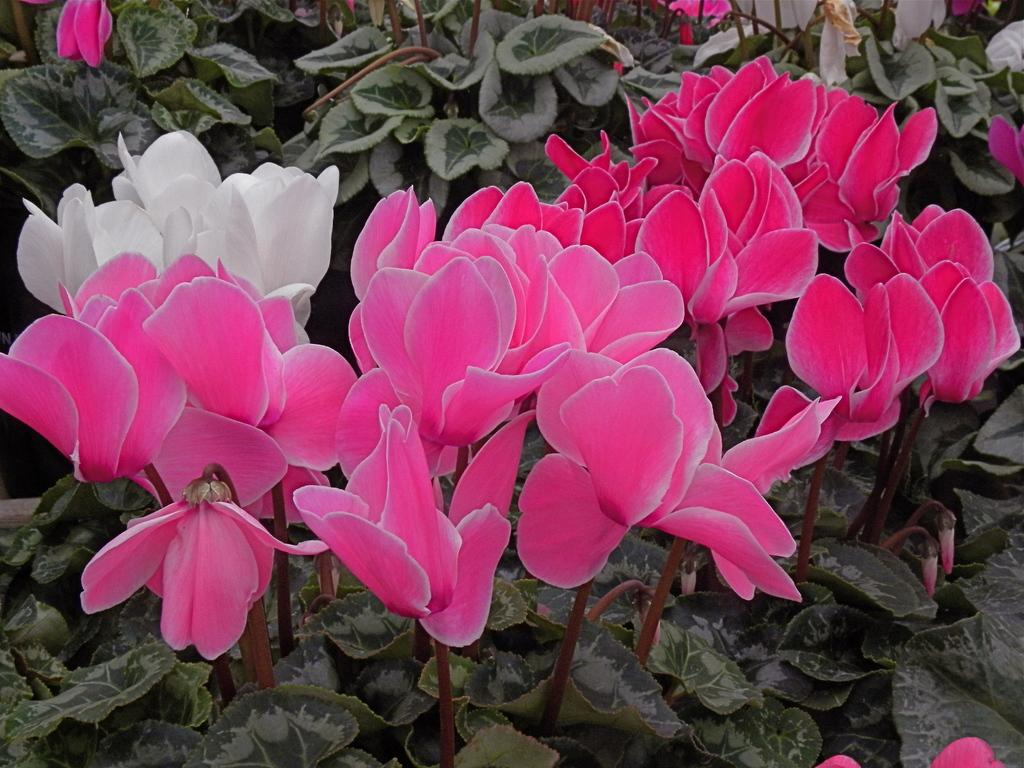What type of flowers are in the foreground of the image? There are lotus flowers in the foreground of the image. What other elements can be seen at the bottom of the image? There are leaves and buds at the bottom of the image. What can be observed in the background of the image? There are plants and flowers in the background of the image. What direction is the bear facing in the image? There is no bear present in the image. 